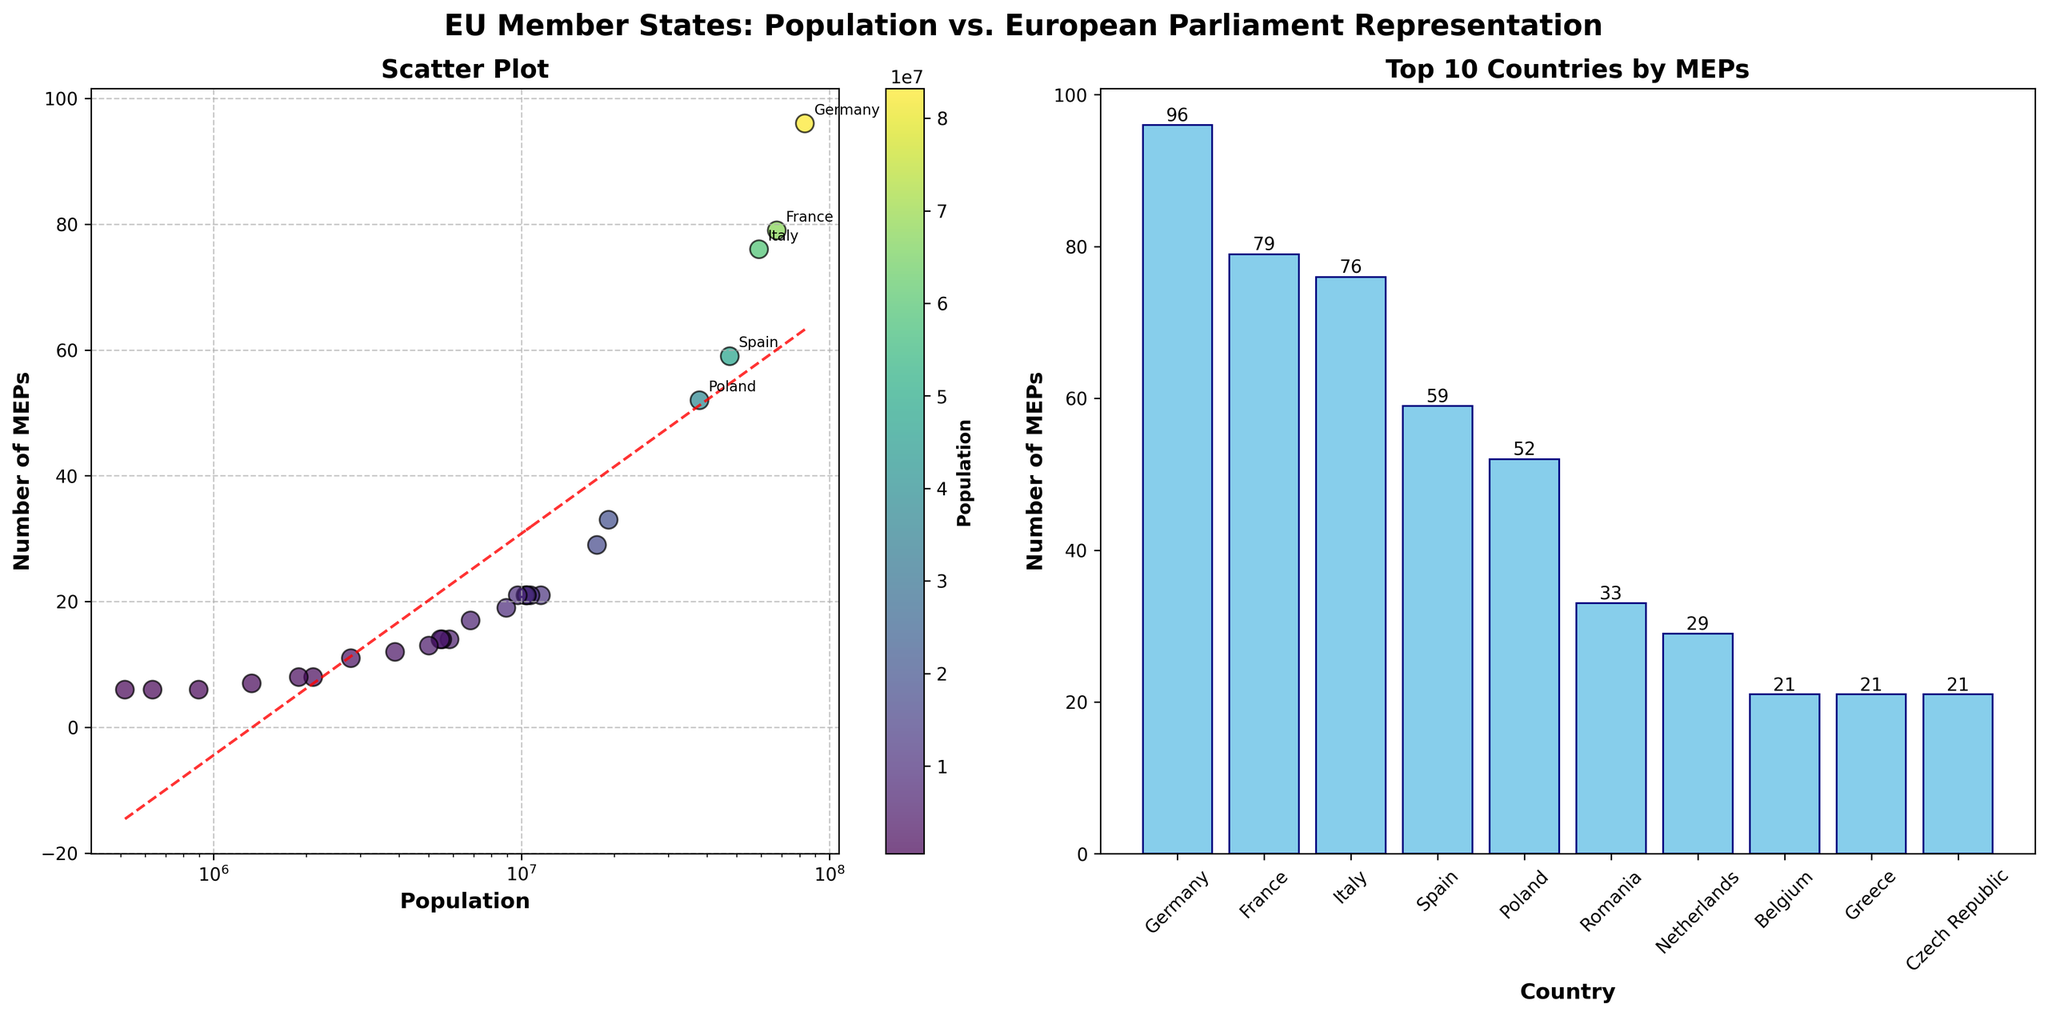What is the range of the number of MEPs for the countries shown in the bar plot? The bar plot shows the top 10 countries by the number of MEPs. The range is calculated as the difference between the highest number of MEPs (96 for Germany) and the lowest number of MEPs among the top 10 countries (33 for Romania). So, 96 - 33 = 63.
Answer: 63 How many countries have more than 20 MEPs according to the scatter plot? The scatter plot can be read to find the number of countries with more than 20 MEPs. These countries are Germany (96), France (79), Italy (76), Spain (59), Poland (52), and Romania (33), totaling 6 countries.
Answer: 6 Which country has the highest number of MEPs and what is its population? From the bar plot, the country with the highest number of MEPs is Germany, with 96 MEPs. In the scatter plot, Germany's population is labeled as 83,190,556.
Answer: Germany with 83,190,556 population What is the average number of MEPs for the top 5 countries with the largest populations? The top 5 populated countries and their MEPs are Germany (96), France (79), Italy (76), Spain (59), and Poland (52). The average number of MEPs is calculated as (96 + 79 + 76 + 59 + 52) / 5 = 72.4.
Answer: 72.4 Which country plotted in the scatter plot deviates most from the trendline, indicating an outlier? In the scatter plot, Belgium has a noticeably higher number of MEPs (21) than expected for its population (11,566,041), making it an outlier when compared to the trendline.
Answer: Belgium What colors are used to represent countries with a population below 2 million in the scatter plot? In the scatter plot, the color representation is based on population size using a viridis colormap. Countries with populations below 2 million (Latvia, Cyprus, Luxembourg, and Malta) are represented using darker purple to blue shades.
Answer: Darker purple to blue How does the number of MEPs for Spain compare to that of Poland, and which country has a higher representation? Spain has 59 MEPs, whereas Poland has 52 MEPs. Hence, Spain has a higher representation in the European Parliament than Poland.
Answer: Spain What does the red dashed line in the scatter plot represent, and how might it be interpreted? The red dashed line in the scatter plot represents the trendline derived from a linear regression on the log-transformed population data. It indicates the general trend or relationship between the population size and the number of MEPs. Countries below this line have fewer MEPs than the average trend, while those above it have more.
Answer: Trendline indicating the general relationship 